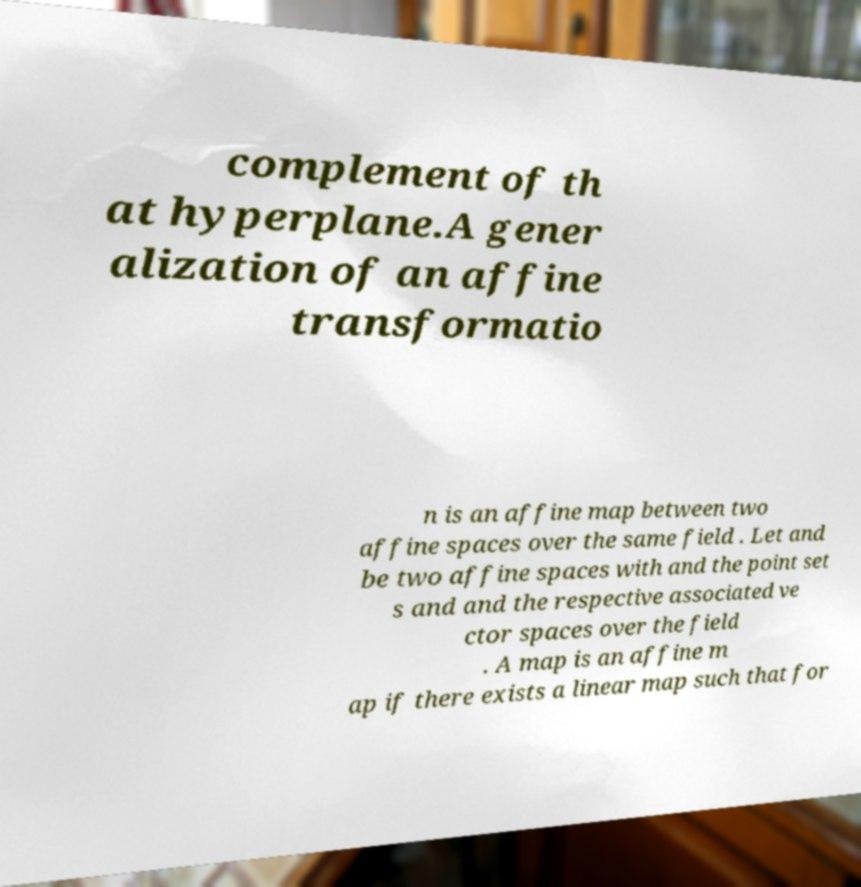For documentation purposes, I need the text within this image transcribed. Could you provide that? complement of th at hyperplane.A gener alization of an affine transformatio n is an affine map between two affine spaces over the same field . Let and be two affine spaces with and the point set s and and the respective associated ve ctor spaces over the field . A map is an affine m ap if there exists a linear map such that for 